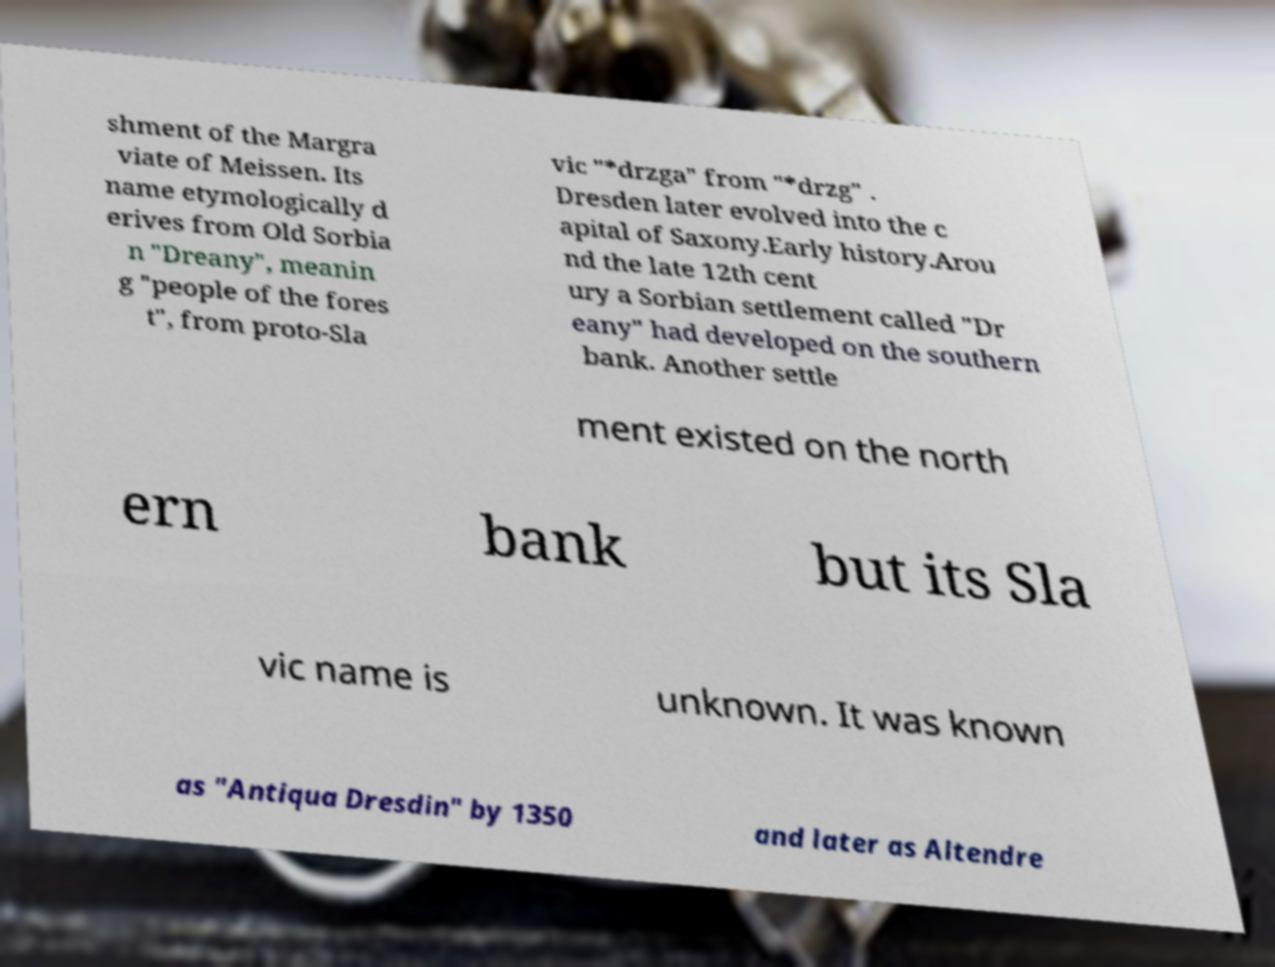I need the written content from this picture converted into text. Can you do that? shment of the Margra viate of Meissen. Its name etymologically d erives from Old Sorbia n "Dreany", meanin g "people of the fores t", from proto-Sla vic "*drzga" from "*drzg" . Dresden later evolved into the c apital of Saxony.Early history.Arou nd the late 12th cent ury a Sorbian settlement called "Dr eany" had developed on the southern bank. Another settle ment existed on the north ern bank but its Sla vic name is unknown. It was known as "Antiqua Dresdin" by 1350 and later as Altendre 